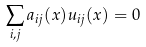Convert formula to latex. <formula><loc_0><loc_0><loc_500><loc_500>\sum _ { i , j } a _ { i j } ( x ) u _ { i j } ( x ) = 0</formula> 